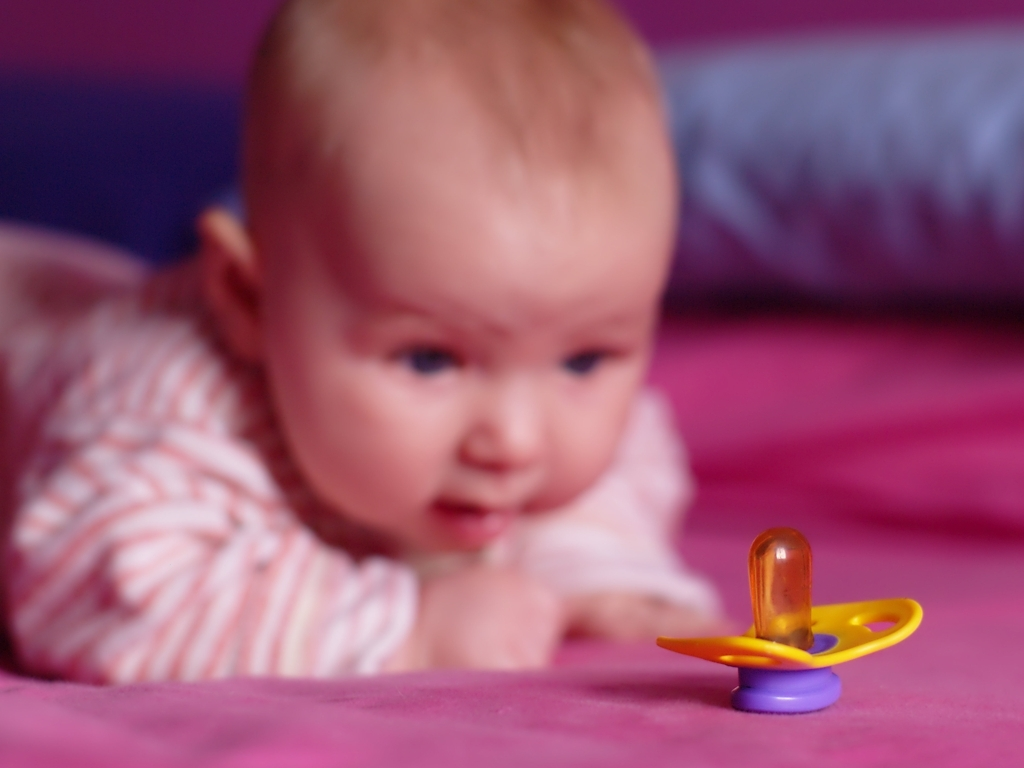What could be the significance of the brightly colored pacifier in the foreground? The placement of the brightly colored pacifier in the foreground against the contrasting purple background draws immediate attention to it. This could symbolize the importance of comfort objects in an infant's life. Additionally, this could represent a moment of independence or growth, as the child may need to learn how to reach and retrieve the pacifier by themselves. The choice of vivid colors might also be intended to reflect the simplicity and joy commonly associated with childhood. 